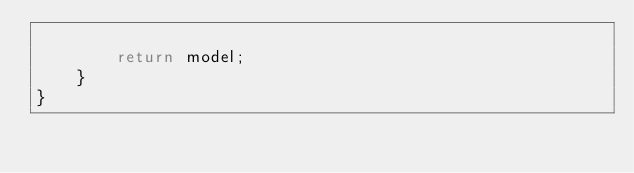Convert code to text. <code><loc_0><loc_0><loc_500><loc_500><_TypeScript_>
        return model;
    }
}
</code> 